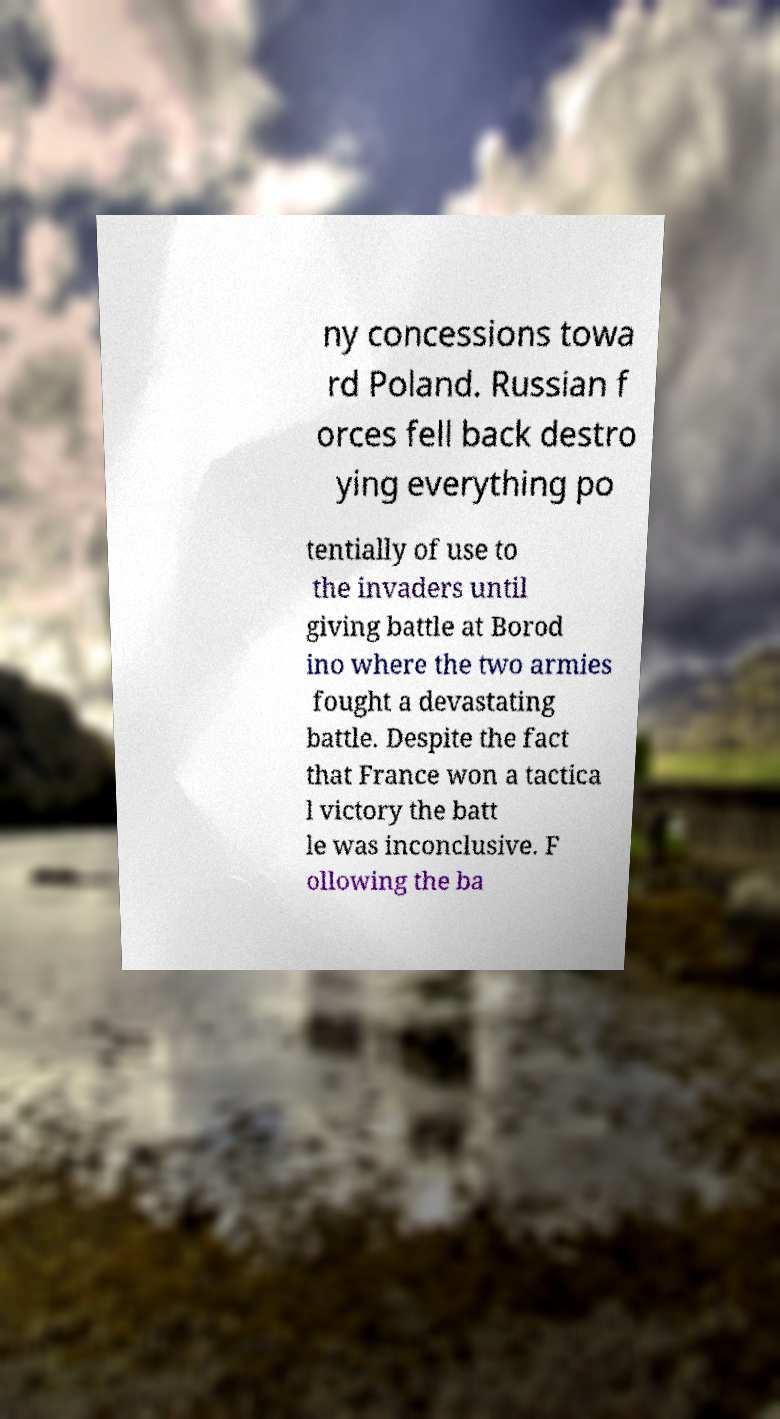Could you extract and type out the text from this image? ny concessions towa rd Poland. Russian f orces fell back destro ying everything po tentially of use to the invaders until giving battle at Borod ino where the two armies fought a devastating battle. Despite the fact that France won a tactica l victory the batt le was inconclusive. F ollowing the ba 